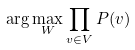<formula> <loc_0><loc_0><loc_500><loc_500>\arg \max _ { W } \prod _ { v \in V } P ( v )</formula> 